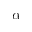Convert formula to latex. <formula><loc_0><loc_0><loc_500><loc_500>\alpha</formula> 